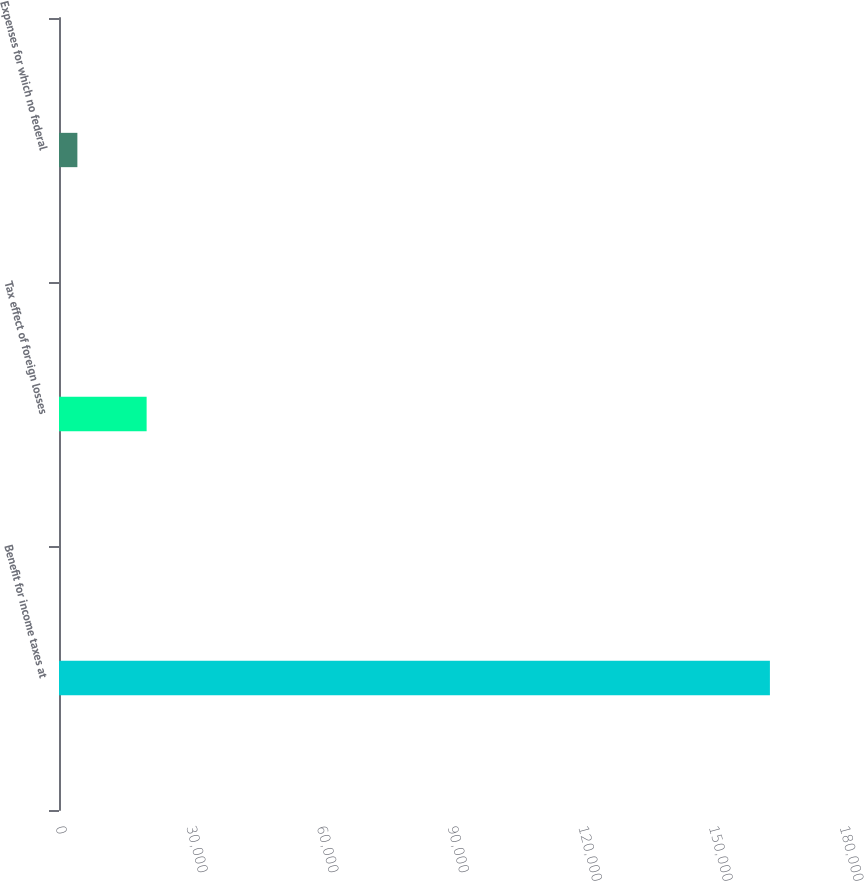<chart> <loc_0><loc_0><loc_500><loc_500><bar_chart><fcel>Benefit for income taxes at<fcel>Tax effect of foreign losses<fcel>Expenses for which no federal<nl><fcel>163219<fcel>20119<fcel>4219<nl></chart> 